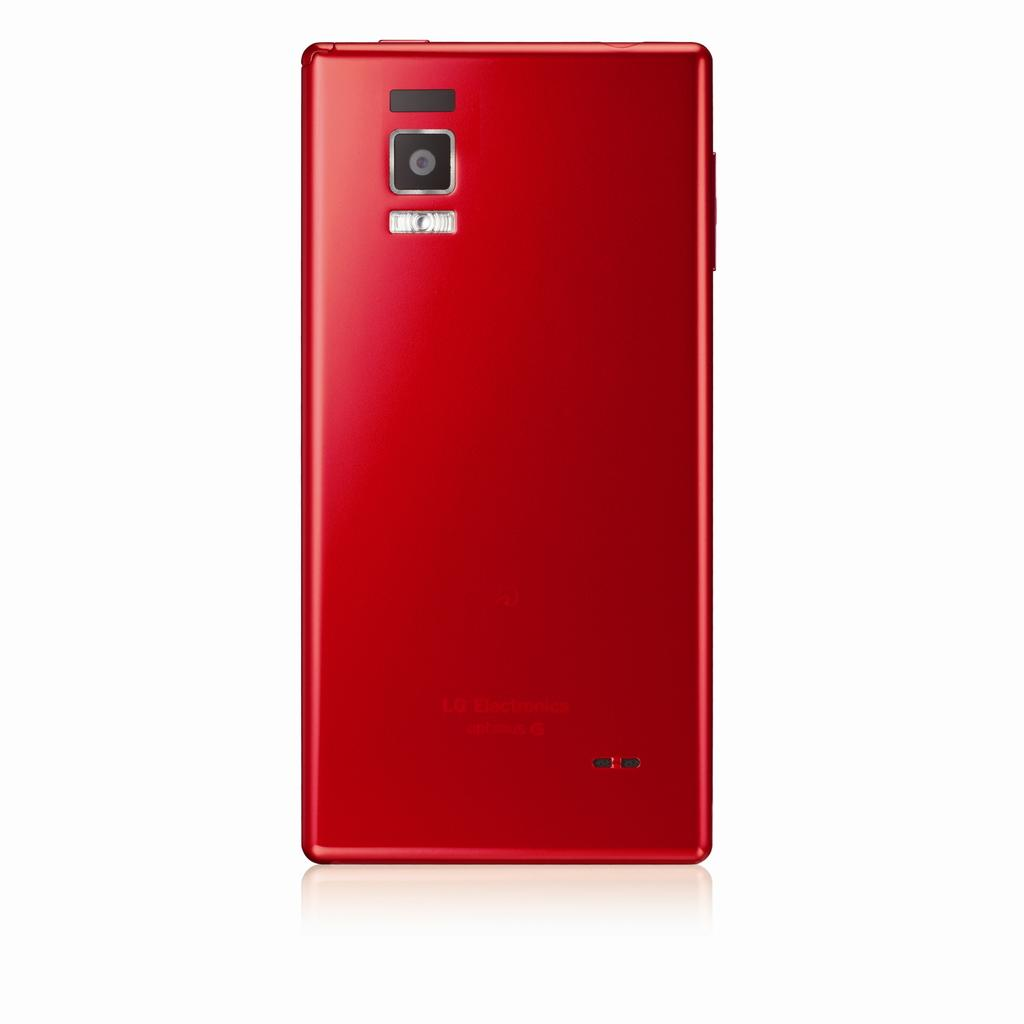<image>
Write a terse but informative summary of the picture. The back of a red LG Electronics device. 